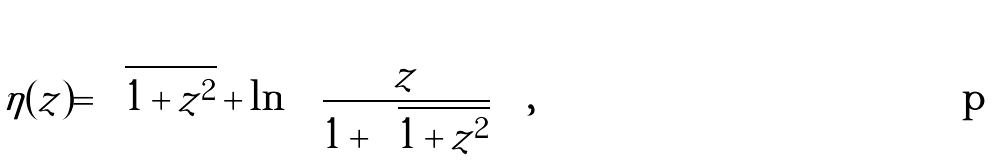<formula> <loc_0><loc_0><loc_500><loc_500>\eta ( z ) = \sqrt { 1 + z ^ { 2 } } + \ln \left ( \frac { z } { 1 + \sqrt { 1 + z ^ { 2 } } } \right ) ,</formula> 